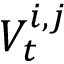Convert formula to latex. <formula><loc_0><loc_0><loc_500><loc_500>V _ { t } ^ { i , j }</formula> 